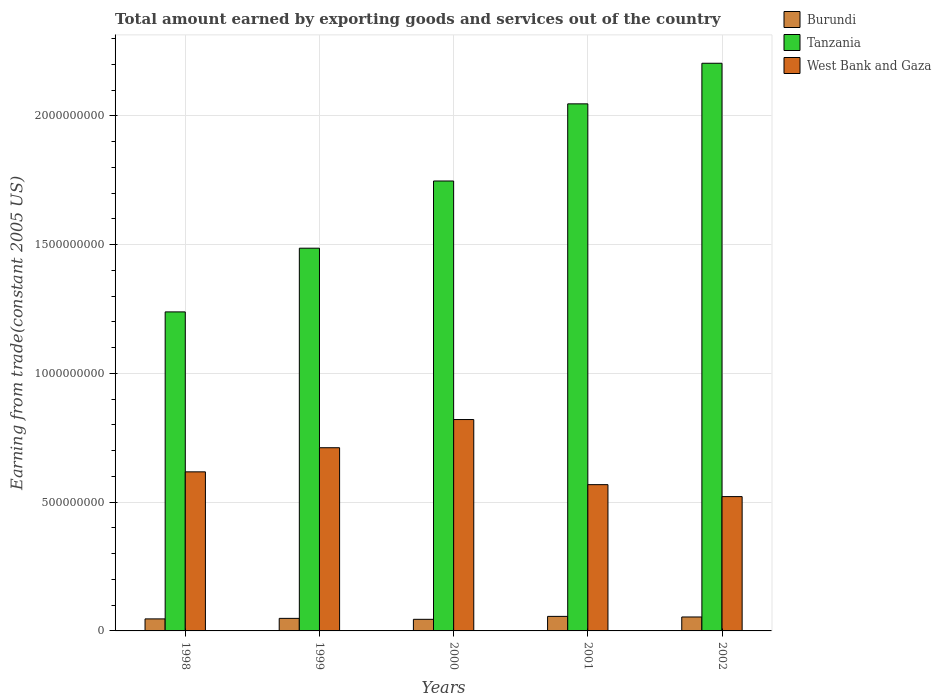In how many cases, is the number of bars for a given year not equal to the number of legend labels?
Make the answer very short. 0. What is the total amount earned by exporting goods and services in Tanzania in 2001?
Offer a very short reply. 2.05e+09. Across all years, what is the maximum total amount earned by exporting goods and services in West Bank and Gaza?
Offer a terse response. 8.21e+08. Across all years, what is the minimum total amount earned by exporting goods and services in Tanzania?
Ensure brevity in your answer.  1.24e+09. In which year was the total amount earned by exporting goods and services in West Bank and Gaza maximum?
Your response must be concise. 2000. What is the total total amount earned by exporting goods and services in Burundi in the graph?
Ensure brevity in your answer.  2.51e+08. What is the difference between the total amount earned by exporting goods and services in Burundi in 1998 and that in 2001?
Give a very brief answer. -9.77e+06. What is the difference between the total amount earned by exporting goods and services in West Bank and Gaza in 2001 and the total amount earned by exporting goods and services in Tanzania in 1999?
Offer a terse response. -9.18e+08. What is the average total amount earned by exporting goods and services in Tanzania per year?
Provide a short and direct response. 1.74e+09. In the year 2000, what is the difference between the total amount earned by exporting goods and services in Burundi and total amount earned by exporting goods and services in West Bank and Gaza?
Offer a very short reply. -7.76e+08. What is the ratio of the total amount earned by exporting goods and services in Burundi in 1999 to that in 2001?
Make the answer very short. 0.86. Is the difference between the total amount earned by exporting goods and services in Burundi in 1999 and 2000 greater than the difference between the total amount earned by exporting goods and services in West Bank and Gaza in 1999 and 2000?
Keep it short and to the point. Yes. What is the difference between the highest and the second highest total amount earned by exporting goods and services in West Bank and Gaza?
Give a very brief answer. 1.09e+08. What is the difference between the highest and the lowest total amount earned by exporting goods and services in West Bank and Gaza?
Your answer should be compact. 2.99e+08. In how many years, is the total amount earned by exporting goods and services in Tanzania greater than the average total amount earned by exporting goods and services in Tanzania taken over all years?
Ensure brevity in your answer.  3. What does the 2nd bar from the left in 2000 represents?
Provide a short and direct response. Tanzania. What does the 2nd bar from the right in 1999 represents?
Offer a very short reply. Tanzania. Is it the case that in every year, the sum of the total amount earned by exporting goods and services in West Bank and Gaza and total amount earned by exporting goods and services in Tanzania is greater than the total amount earned by exporting goods and services in Burundi?
Ensure brevity in your answer.  Yes. How many bars are there?
Make the answer very short. 15. What is the difference between two consecutive major ticks on the Y-axis?
Make the answer very short. 5.00e+08. Does the graph contain any zero values?
Your answer should be compact. No. How many legend labels are there?
Your answer should be compact. 3. What is the title of the graph?
Provide a succinct answer. Total amount earned by exporting goods and services out of the country. Does "Guinea-Bissau" appear as one of the legend labels in the graph?
Ensure brevity in your answer.  No. What is the label or title of the X-axis?
Your answer should be very brief. Years. What is the label or title of the Y-axis?
Offer a very short reply. Earning from trade(constant 2005 US). What is the Earning from trade(constant 2005 US) of Burundi in 1998?
Make the answer very short. 4.67e+07. What is the Earning from trade(constant 2005 US) in Tanzania in 1998?
Offer a very short reply. 1.24e+09. What is the Earning from trade(constant 2005 US) of West Bank and Gaza in 1998?
Keep it short and to the point. 6.18e+08. What is the Earning from trade(constant 2005 US) of Burundi in 1999?
Your response must be concise. 4.87e+07. What is the Earning from trade(constant 2005 US) in Tanzania in 1999?
Provide a short and direct response. 1.49e+09. What is the Earning from trade(constant 2005 US) of West Bank and Gaza in 1999?
Provide a succinct answer. 7.11e+08. What is the Earning from trade(constant 2005 US) in Burundi in 2000?
Offer a very short reply. 4.50e+07. What is the Earning from trade(constant 2005 US) in Tanzania in 2000?
Provide a succinct answer. 1.75e+09. What is the Earning from trade(constant 2005 US) in West Bank and Gaza in 2000?
Provide a succinct answer. 8.21e+08. What is the Earning from trade(constant 2005 US) of Burundi in 2001?
Provide a succinct answer. 5.65e+07. What is the Earning from trade(constant 2005 US) of Tanzania in 2001?
Make the answer very short. 2.05e+09. What is the Earning from trade(constant 2005 US) of West Bank and Gaza in 2001?
Your answer should be very brief. 5.68e+08. What is the Earning from trade(constant 2005 US) in Burundi in 2002?
Your answer should be compact. 5.41e+07. What is the Earning from trade(constant 2005 US) in Tanzania in 2002?
Offer a very short reply. 2.20e+09. What is the Earning from trade(constant 2005 US) of West Bank and Gaza in 2002?
Keep it short and to the point. 5.22e+08. Across all years, what is the maximum Earning from trade(constant 2005 US) of Burundi?
Give a very brief answer. 5.65e+07. Across all years, what is the maximum Earning from trade(constant 2005 US) of Tanzania?
Your answer should be compact. 2.20e+09. Across all years, what is the maximum Earning from trade(constant 2005 US) in West Bank and Gaza?
Provide a succinct answer. 8.21e+08. Across all years, what is the minimum Earning from trade(constant 2005 US) in Burundi?
Your response must be concise. 4.50e+07. Across all years, what is the minimum Earning from trade(constant 2005 US) of Tanzania?
Make the answer very short. 1.24e+09. Across all years, what is the minimum Earning from trade(constant 2005 US) in West Bank and Gaza?
Your response must be concise. 5.22e+08. What is the total Earning from trade(constant 2005 US) in Burundi in the graph?
Keep it short and to the point. 2.51e+08. What is the total Earning from trade(constant 2005 US) in Tanzania in the graph?
Offer a very short reply. 8.72e+09. What is the total Earning from trade(constant 2005 US) in West Bank and Gaza in the graph?
Make the answer very short. 3.24e+09. What is the difference between the Earning from trade(constant 2005 US) of Burundi in 1998 and that in 1999?
Your answer should be very brief. -2.03e+06. What is the difference between the Earning from trade(constant 2005 US) of Tanzania in 1998 and that in 1999?
Give a very brief answer. -2.47e+08. What is the difference between the Earning from trade(constant 2005 US) of West Bank and Gaza in 1998 and that in 1999?
Provide a succinct answer. -9.36e+07. What is the difference between the Earning from trade(constant 2005 US) of Burundi in 1998 and that in 2000?
Provide a succinct answer. 1.67e+06. What is the difference between the Earning from trade(constant 2005 US) in Tanzania in 1998 and that in 2000?
Give a very brief answer. -5.08e+08. What is the difference between the Earning from trade(constant 2005 US) of West Bank and Gaza in 1998 and that in 2000?
Offer a very short reply. -2.03e+08. What is the difference between the Earning from trade(constant 2005 US) in Burundi in 1998 and that in 2001?
Your answer should be compact. -9.77e+06. What is the difference between the Earning from trade(constant 2005 US) of Tanzania in 1998 and that in 2001?
Keep it short and to the point. -8.08e+08. What is the difference between the Earning from trade(constant 2005 US) of West Bank and Gaza in 1998 and that in 2001?
Offer a terse response. 4.97e+07. What is the difference between the Earning from trade(constant 2005 US) in Burundi in 1998 and that in 2002?
Provide a short and direct response. -7.43e+06. What is the difference between the Earning from trade(constant 2005 US) of Tanzania in 1998 and that in 2002?
Your response must be concise. -9.65e+08. What is the difference between the Earning from trade(constant 2005 US) in West Bank and Gaza in 1998 and that in 2002?
Provide a succinct answer. 9.61e+07. What is the difference between the Earning from trade(constant 2005 US) of Burundi in 1999 and that in 2000?
Ensure brevity in your answer.  3.70e+06. What is the difference between the Earning from trade(constant 2005 US) in Tanzania in 1999 and that in 2000?
Make the answer very short. -2.61e+08. What is the difference between the Earning from trade(constant 2005 US) in West Bank and Gaza in 1999 and that in 2000?
Provide a succinct answer. -1.09e+08. What is the difference between the Earning from trade(constant 2005 US) in Burundi in 1999 and that in 2001?
Keep it short and to the point. -7.73e+06. What is the difference between the Earning from trade(constant 2005 US) of Tanzania in 1999 and that in 2001?
Your response must be concise. -5.60e+08. What is the difference between the Earning from trade(constant 2005 US) of West Bank and Gaza in 1999 and that in 2001?
Your answer should be very brief. 1.43e+08. What is the difference between the Earning from trade(constant 2005 US) in Burundi in 1999 and that in 2002?
Your response must be concise. -5.39e+06. What is the difference between the Earning from trade(constant 2005 US) in Tanzania in 1999 and that in 2002?
Keep it short and to the point. -7.18e+08. What is the difference between the Earning from trade(constant 2005 US) of West Bank and Gaza in 1999 and that in 2002?
Ensure brevity in your answer.  1.90e+08. What is the difference between the Earning from trade(constant 2005 US) in Burundi in 2000 and that in 2001?
Give a very brief answer. -1.14e+07. What is the difference between the Earning from trade(constant 2005 US) in Tanzania in 2000 and that in 2001?
Make the answer very short. -3.00e+08. What is the difference between the Earning from trade(constant 2005 US) of West Bank and Gaza in 2000 and that in 2001?
Your answer should be very brief. 2.53e+08. What is the difference between the Earning from trade(constant 2005 US) of Burundi in 2000 and that in 2002?
Offer a terse response. -9.10e+06. What is the difference between the Earning from trade(constant 2005 US) in Tanzania in 2000 and that in 2002?
Offer a very short reply. -4.57e+08. What is the difference between the Earning from trade(constant 2005 US) of West Bank and Gaza in 2000 and that in 2002?
Your answer should be compact. 2.99e+08. What is the difference between the Earning from trade(constant 2005 US) of Burundi in 2001 and that in 2002?
Your response must be concise. 2.34e+06. What is the difference between the Earning from trade(constant 2005 US) in Tanzania in 2001 and that in 2002?
Give a very brief answer. -1.58e+08. What is the difference between the Earning from trade(constant 2005 US) of West Bank and Gaza in 2001 and that in 2002?
Your answer should be compact. 4.64e+07. What is the difference between the Earning from trade(constant 2005 US) of Burundi in 1998 and the Earning from trade(constant 2005 US) of Tanzania in 1999?
Provide a short and direct response. -1.44e+09. What is the difference between the Earning from trade(constant 2005 US) in Burundi in 1998 and the Earning from trade(constant 2005 US) in West Bank and Gaza in 1999?
Your response must be concise. -6.65e+08. What is the difference between the Earning from trade(constant 2005 US) of Tanzania in 1998 and the Earning from trade(constant 2005 US) of West Bank and Gaza in 1999?
Offer a very short reply. 5.27e+08. What is the difference between the Earning from trade(constant 2005 US) in Burundi in 1998 and the Earning from trade(constant 2005 US) in Tanzania in 2000?
Keep it short and to the point. -1.70e+09. What is the difference between the Earning from trade(constant 2005 US) in Burundi in 1998 and the Earning from trade(constant 2005 US) in West Bank and Gaza in 2000?
Your answer should be compact. -7.74e+08. What is the difference between the Earning from trade(constant 2005 US) of Tanzania in 1998 and the Earning from trade(constant 2005 US) of West Bank and Gaza in 2000?
Make the answer very short. 4.18e+08. What is the difference between the Earning from trade(constant 2005 US) in Burundi in 1998 and the Earning from trade(constant 2005 US) in Tanzania in 2001?
Make the answer very short. -2.00e+09. What is the difference between the Earning from trade(constant 2005 US) in Burundi in 1998 and the Earning from trade(constant 2005 US) in West Bank and Gaza in 2001?
Ensure brevity in your answer.  -5.21e+08. What is the difference between the Earning from trade(constant 2005 US) in Tanzania in 1998 and the Earning from trade(constant 2005 US) in West Bank and Gaza in 2001?
Your response must be concise. 6.71e+08. What is the difference between the Earning from trade(constant 2005 US) in Burundi in 1998 and the Earning from trade(constant 2005 US) in Tanzania in 2002?
Keep it short and to the point. -2.16e+09. What is the difference between the Earning from trade(constant 2005 US) of Burundi in 1998 and the Earning from trade(constant 2005 US) of West Bank and Gaza in 2002?
Ensure brevity in your answer.  -4.75e+08. What is the difference between the Earning from trade(constant 2005 US) of Tanzania in 1998 and the Earning from trade(constant 2005 US) of West Bank and Gaza in 2002?
Your response must be concise. 7.17e+08. What is the difference between the Earning from trade(constant 2005 US) of Burundi in 1999 and the Earning from trade(constant 2005 US) of Tanzania in 2000?
Your answer should be very brief. -1.70e+09. What is the difference between the Earning from trade(constant 2005 US) of Burundi in 1999 and the Earning from trade(constant 2005 US) of West Bank and Gaza in 2000?
Keep it short and to the point. -7.72e+08. What is the difference between the Earning from trade(constant 2005 US) of Tanzania in 1999 and the Earning from trade(constant 2005 US) of West Bank and Gaza in 2000?
Your answer should be compact. 6.65e+08. What is the difference between the Earning from trade(constant 2005 US) of Burundi in 1999 and the Earning from trade(constant 2005 US) of Tanzania in 2001?
Provide a short and direct response. -2.00e+09. What is the difference between the Earning from trade(constant 2005 US) of Burundi in 1999 and the Earning from trade(constant 2005 US) of West Bank and Gaza in 2001?
Your answer should be compact. -5.19e+08. What is the difference between the Earning from trade(constant 2005 US) in Tanzania in 1999 and the Earning from trade(constant 2005 US) in West Bank and Gaza in 2001?
Your answer should be very brief. 9.18e+08. What is the difference between the Earning from trade(constant 2005 US) in Burundi in 1999 and the Earning from trade(constant 2005 US) in Tanzania in 2002?
Give a very brief answer. -2.16e+09. What is the difference between the Earning from trade(constant 2005 US) of Burundi in 1999 and the Earning from trade(constant 2005 US) of West Bank and Gaza in 2002?
Offer a terse response. -4.73e+08. What is the difference between the Earning from trade(constant 2005 US) in Tanzania in 1999 and the Earning from trade(constant 2005 US) in West Bank and Gaza in 2002?
Offer a very short reply. 9.65e+08. What is the difference between the Earning from trade(constant 2005 US) in Burundi in 2000 and the Earning from trade(constant 2005 US) in Tanzania in 2001?
Your response must be concise. -2.00e+09. What is the difference between the Earning from trade(constant 2005 US) of Burundi in 2000 and the Earning from trade(constant 2005 US) of West Bank and Gaza in 2001?
Keep it short and to the point. -5.23e+08. What is the difference between the Earning from trade(constant 2005 US) in Tanzania in 2000 and the Earning from trade(constant 2005 US) in West Bank and Gaza in 2001?
Provide a short and direct response. 1.18e+09. What is the difference between the Earning from trade(constant 2005 US) of Burundi in 2000 and the Earning from trade(constant 2005 US) of Tanzania in 2002?
Your answer should be compact. -2.16e+09. What is the difference between the Earning from trade(constant 2005 US) of Burundi in 2000 and the Earning from trade(constant 2005 US) of West Bank and Gaza in 2002?
Provide a short and direct response. -4.77e+08. What is the difference between the Earning from trade(constant 2005 US) in Tanzania in 2000 and the Earning from trade(constant 2005 US) in West Bank and Gaza in 2002?
Keep it short and to the point. 1.23e+09. What is the difference between the Earning from trade(constant 2005 US) of Burundi in 2001 and the Earning from trade(constant 2005 US) of Tanzania in 2002?
Give a very brief answer. -2.15e+09. What is the difference between the Earning from trade(constant 2005 US) in Burundi in 2001 and the Earning from trade(constant 2005 US) in West Bank and Gaza in 2002?
Ensure brevity in your answer.  -4.65e+08. What is the difference between the Earning from trade(constant 2005 US) of Tanzania in 2001 and the Earning from trade(constant 2005 US) of West Bank and Gaza in 2002?
Give a very brief answer. 1.52e+09. What is the average Earning from trade(constant 2005 US) of Burundi per year?
Ensure brevity in your answer.  5.02e+07. What is the average Earning from trade(constant 2005 US) in Tanzania per year?
Provide a short and direct response. 1.74e+09. What is the average Earning from trade(constant 2005 US) of West Bank and Gaza per year?
Provide a short and direct response. 6.48e+08. In the year 1998, what is the difference between the Earning from trade(constant 2005 US) in Burundi and Earning from trade(constant 2005 US) in Tanzania?
Offer a terse response. -1.19e+09. In the year 1998, what is the difference between the Earning from trade(constant 2005 US) of Burundi and Earning from trade(constant 2005 US) of West Bank and Gaza?
Provide a succinct answer. -5.71e+08. In the year 1998, what is the difference between the Earning from trade(constant 2005 US) in Tanzania and Earning from trade(constant 2005 US) in West Bank and Gaza?
Your answer should be compact. 6.21e+08. In the year 1999, what is the difference between the Earning from trade(constant 2005 US) of Burundi and Earning from trade(constant 2005 US) of Tanzania?
Offer a very short reply. -1.44e+09. In the year 1999, what is the difference between the Earning from trade(constant 2005 US) in Burundi and Earning from trade(constant 2005 US) in West Bank and Gaza?
Offer a very short reply. -6.63e+08. In the year 1999, what is the difference between the Earning from trade(constant 2005 US) of Tanzania and Earning from trade(constant 2005 US) of West Bank and Gaza?
Give a very brief answer. 7.75e+08. In the year 2000, what is the difference between the Earning from trade(constant 2005 US) in Burundi and Earning from trade(constant 2005 US) in Tanzania?
Offer a terse response. -1.70e+09. In the year 2000, what is the difference between the Earning from trade(constant 2005 US) in Burundi and Earning from trade(constant 2005 US) in West Bank and Gaza?
Your answer should be very brief. -7.76e+08. In the year 2000, what is the difference between the Earning from trade(constant 2005 US) of Tanzania and Earning from trade(constant 2005 US) of West Bank and Gaza?
Your answer should be compact. 9.26e+08. In the year 2001, what is the difference between the Earning from trade(constant 2005 US) of Burundi and Earning from trade(constant 2005 US) of Tanzania?
Your answer should be very brief. -1.99e+09. In the year 2001, what is the difference between the Earning from trade(constant 2005 US) of Burundi and Earning from trade(constant 2005 US) of West Bank and Gaza?
Your answer should be compact. -5.11e+08. In the year 2001, what is the difference between the Earning from trade(constant 2005 US) of Tanzania and Earning from trade(constant 2005 US) of West Bank and Gaza?
Keep it short and to the point. 1.48e+09. In the year 2002, what is the difference between the Earning from trade(constant 2005 US) of Burundi and Earning from trade(constant 2005 US) of Tanzania?
Your response must be concise. -2.15e+09. In the year 2002, what is the difference between the Earning from trade(constant 2005 US) of Burundi and Earning from trade(constant 2005 US) of West Bank and Gaza?
Offer a terse response. -4.67e+08. In the year 2002, what is the difference between the Earning from trade(constant 2005 US) in Tanzania and Earning from trade(constant 2005 US) in West Bank and Gaza?
Your answer should be very brief. 1.68e+09. What is the ratio of the Earning from trade(constant 2005 US) in Tanzania in 1998 to that in 1999?
Ensure brevity in your answer.  0.83. What is the ratio of the Earning from trade(constant 2005 US) of West Bank and Gaza in 1998 to that in 1999?
Keep it short and to the point. 0.87. What is the ratio of the Earning from trade(constant 2005 US) in Burundi in 1998 to that in 2000?
Keep it short and to the point. 1.04. What is the ratio of the Earning from trade(constant 2005 US) of Tanzania in 1998 to that in 2000?
Provide a succinct answer. 0.71. What is the ratio of the Earning from trade(constant 2005 US) of West Bank and Gaza in 1998 to that in 2000?
Your response must be concise. 0.75. What is the ratio of the Earning from trade(constant 2005 US) in Burundi in 1998 to that in 2001?
Make the answer very short. 0.83. What is the ratio of the Earning from trade(constant 2005 US) of Tanzania in 1998 to that in 2001?
Provide a succinct answer. 0.61. What is the ratio of the Earning from trade(constant 2005 US) in West Bank and Gaza in 1998 to that in 2001?
Ensure brevity in your answer.  1.09. What is the ratio of the Earning from trade(constant 2005 US) in Burundi in 1998 to that in 2002?
Provide a succinct answer. 0.86. What is the ratio of the Earning from trade(constant 2005 US) of Tanzania in 1998 to that in 2002?
Ensure brevity in your answer.  0.56. What is the ratio of the Earning from trade(constant 2005 US) in West Bank and Gaza in 1998 to that in 2002?
Provide a succinct answer. 1.18. What is the ratio of the Earning from trade(constant 2005 US) in Burundi in 1999 to that in 2000?
Give a very brief answer. 1.08. What is the ratio of the Earning from trade(constant 2005 US) of Tanzania in 1999 to that in 2000?
Keep it short and to the point. 0.85. What is the ratio of the Earning from trade(constant 2005 US) in West Bank and Gaza in 1999 to that in 2000?
Your answer should be very brief. 0.87. What is the ratio of the Earning from trade(constant 2005 US) of Burundi in 1999 to that in 2001?
Your response must be concise. 0.86. What is the ratio of the Earning from trade(constant 2005 US) of Tanzania in 1999 to that in 2001?
Offer a very short reply. 0.73. What is the ratio of the Earning from trade(constant 2005 US) of West Bank and Gaza in 1999 to that in 2001?
Your answer should be very brief. 1.25. What is the ratio of the Earning from trade(constant 2005 US) in Burundi in 1999 to that in 2002?
Offer a terse response. 0.9. What is the ratio of the Earning from trade(constant 2005 US) of Tanzania in 1999 to that in 2002?
Offer a very short reply. 0.67. What is the ratio of the Earning from trade(constant 2005 US) in West Bank and Gaza in 1999 to that in 2002?
Provide a short and direct response. 1.36. What is the ratio of the Earning from trade(constant 2005 US) in Burundi in 2000 to that in 2001?
Ensure brevity in your answer.  0.8. What is the ratio of the Earning from trade(constant 2005 US) of Tanzania in 2000 to that in 2001?
Offer a very short reply. 0.85. What is the ratio of the Earning from trade(constant 2005 US) in West Bank and Gaza in 2000 to that in 2001?
Ensure brevity in your answer.  1.45. What is the ratio of the Earning from trade(constant 2005 US) in Burundi in 2000 to that in 2002?
Offer a terse response. 0.83. What is the ratio of the Earning from trade(constant 2005 US) of Tanzania in 2000 to that in 2002?
Offer a terse response. 0.79. What is the ratio of the Earning from trade(constant 2005 US) in West Bank and Gaza in 2000 to that in 2002?
Offer a terse response. 1.57. What is the ratio of the Earning from trade(constant 2005 US) in Burundi in 2001 to that in 2002?
Offer a very short reply. 1.04. What is the ratio of the Earning from trade(constant 2005 US) in Tanzania in 2001 to that in 2002?
Your response must be concise. 0.93. What is the ratio of the Earning from trade(constant 2005 US) in West Bank and Gaza in 2001 to that in 2002?
Offer a terse response. 1.09. What is the difference between the highest and the second highest Earning from trade(constant 2005 US) of Burundi?
Offer a terse response. 2.34e+06. What is the difference between the highest and the second highest Earning from trade(constant 2005 US) of Tanzania?
Provide a succinct answer. 1.58e+08. What is the difference between the highest and the second highest Earning from trade(constant 2005 US) of West Bank and Gaza?
Offer a terse response. 1.09e+08. What is the difference between the highest and the lowest Earning from trade(constant 2005 US) in Burundi?
Provide a short and direct response. 1.14e+07. What is the difference between the highest and the lowest Earning from trade(constant 2005 US) in Tanzania?
Offer a very short reply. 9.65e+08. What is the difference between the highest and the lowest Earning from trade(constant 2005 US) in West Bank and Gaza?
Your answer should be compact. 2.99e+08. 